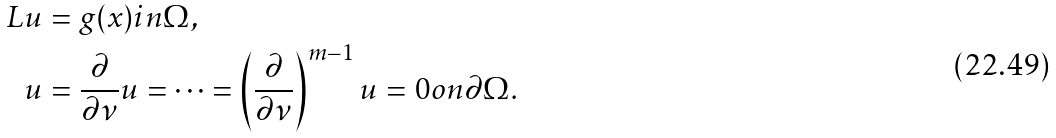Convert formula to latex. <formula><loc_0><loc_0><loc_500><loc_500>L u & = g ( x ) i n \Omega , \\ u & = \frac { \partial } { \partial \nu } u = \dots = \left ( \frac { \partial } { \partial \nu } \right ) ^ { m - 1 } u = 0 o n \partial \Omega .</formula> 